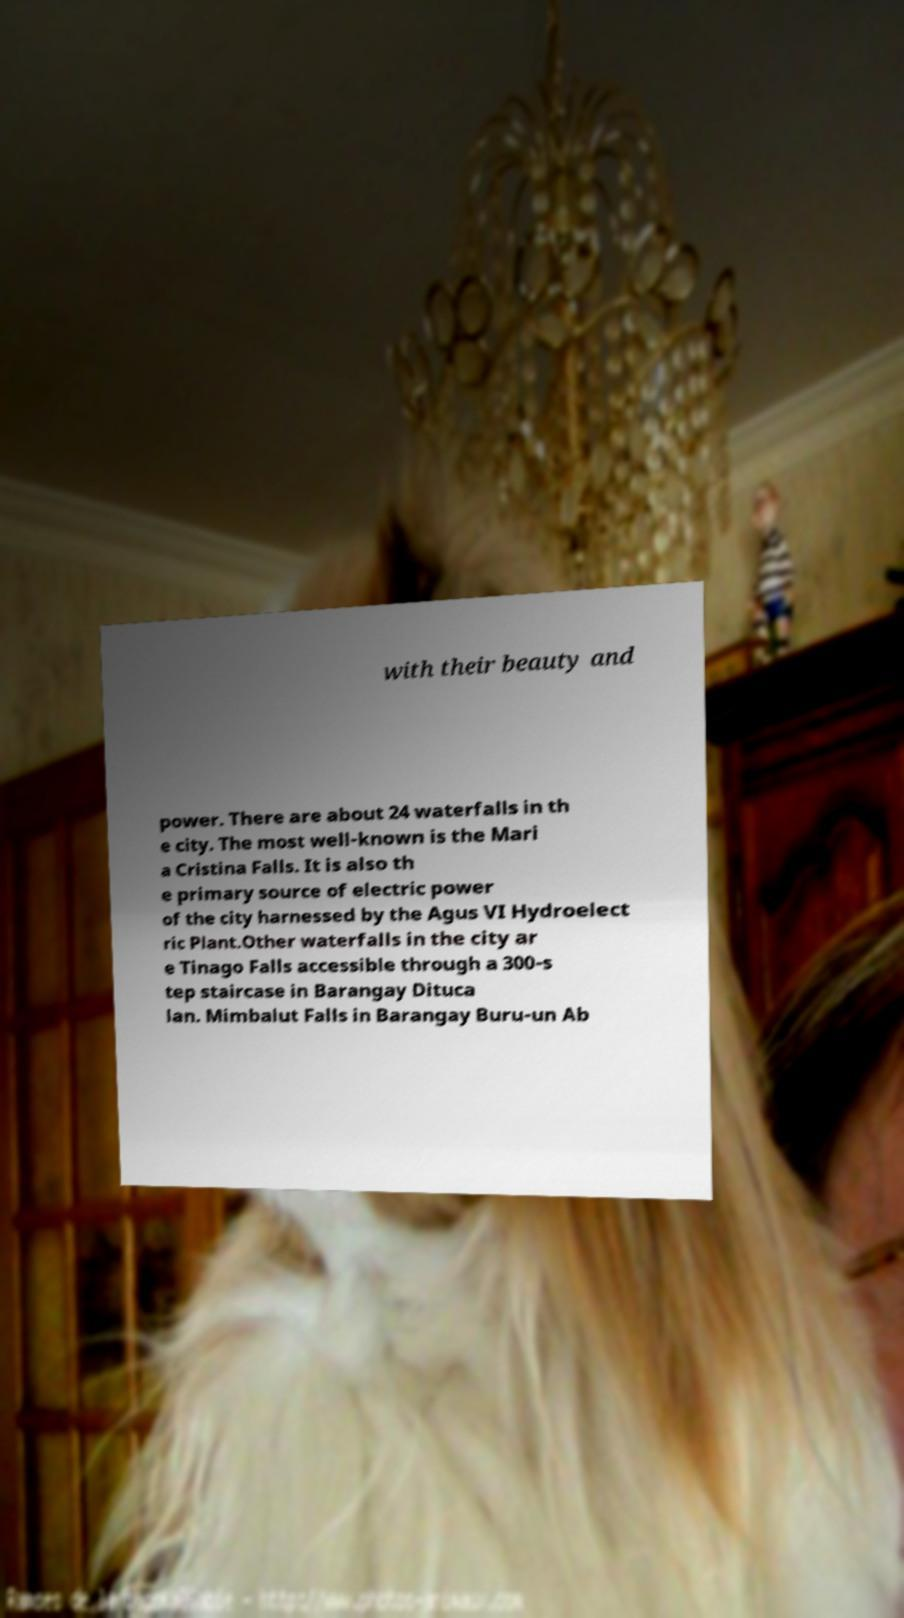There's text embedded in this image that I need extracted. Can you transcribe it verbatim? with their beauty and power. There are about 24 waterfalls in th e city. The most well-known is the Mari a Cristina Falls. It is also th e primary source of electric power of the city harnessed by the Agus VI Hydroelect ric Plant.Other waterfalls in the city ar e Tinago Falls accessible through a 300-s tep staircase in Barangay Dituca lan. Mimbalut Falls in Barangay Buru-un Ab 